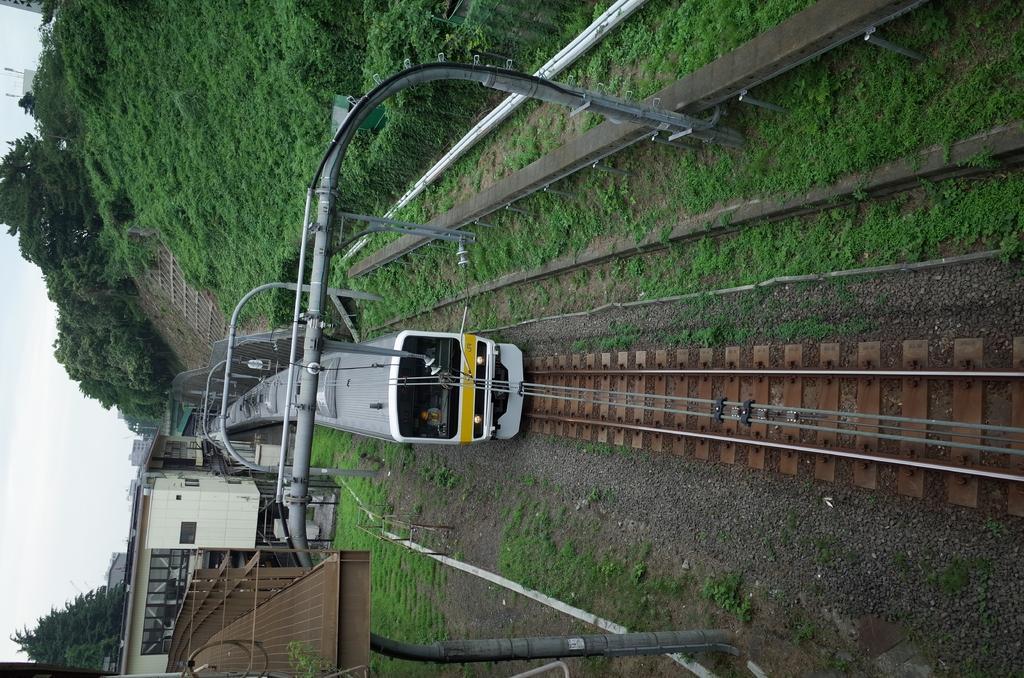How would you summarize this image in a sentence or two? In this picture I can see there is a train moving on the track and there is grass on the floor and there are electric poles, trees and buildings on top and bottom of the image and the sky is clear. 